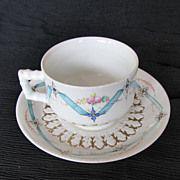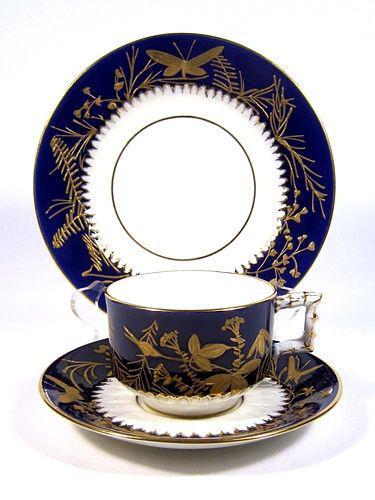The first image is the image on the left, the second image is the image on the right. Examine the images to the left and right. Is the description "One cup is not on a saucer." accurate? Answer yes or no. No. 